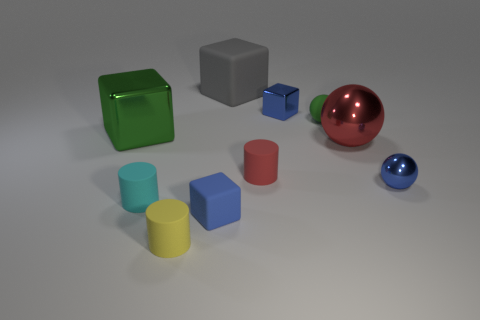Are there any other things that have the same color as the large matte thing?
Offer a terse response. No. The yellow cylinder has what size?
Provide a succinct answer. Small. There is a metal object right of the large red object; how big is it?
Make the answer very short. Small. There is a blue cube that is behind the small metallic sphere; does it have the same size as the metal block left of the tiny yellow rubber cylinder?
Offer a very short reply. No. The tiny metallic sphere has what color?
Ensure brevity in your answer.  Blue. There is a green matte ball; are there any small blue spheres in front of it?
Offer a very short reply. Yes. Does the tiny metal sphere have the same color as the small metal cube?
Provide a succinct answer. Yes. How many large metallic objects have the same color as the large matte cube?
Offer a terse response. 0. What is the size of the metal block that is on the left side of the big thing behind the tiny green matte ball?
Offer a very short reply. Large. The green metal object has what shape?
Provide a succinct answer. Cube. 